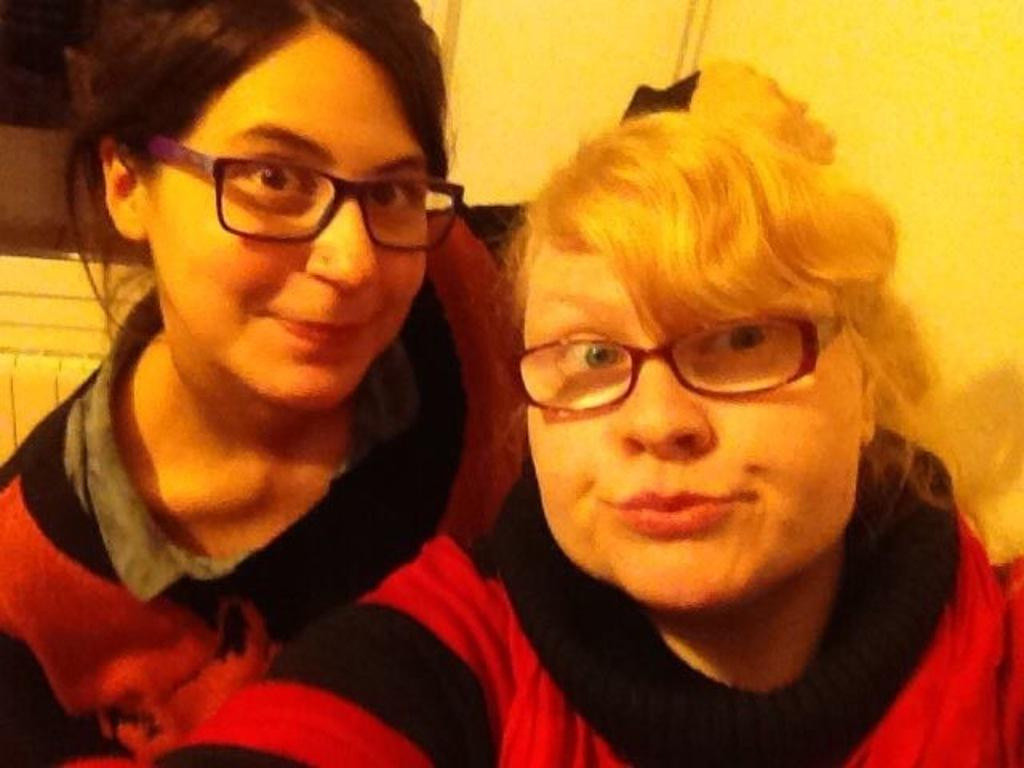How many people are in the image? There are two ladies in the center of the image. What are the ladies wearing on their faces? Both ladies are wearing spectacles. What can be seen behind the ladies in the image? There is a wall in the background of the image. What type of treatment is the lady on the left receiving in the image? There is no indication in the image that the lady on the left is receiving any treatment. 